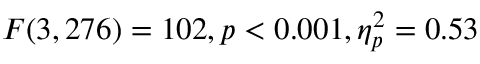Convert formula to latex. <formula><loc_0><loc_0><loc_500><loc_500>F ( 3 , 2 7 6 ) = 1 0 2 , p < 0 . 0 0 1 , \eta _ { p } ^ { 2 } = 0 . 5 3</formula> 